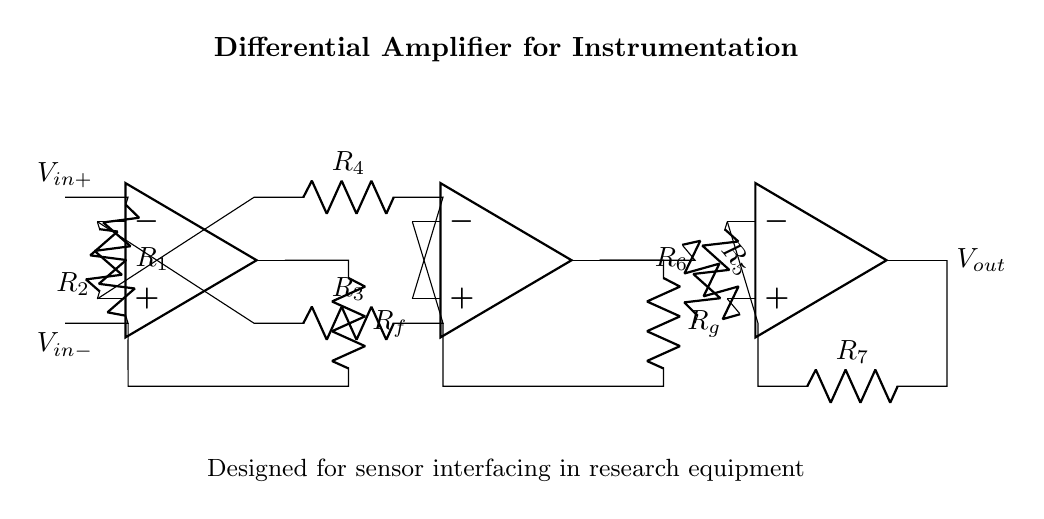What are the resistors labeled R1 and R2 used for? R1 and R2 are connected to the non-inverting and inverting inputs of the first operational amplifier, respectively, forming the input stage of the differential amplifier.
Answer: Input resistors What is the role of the operational amplifiers in this circuit? The operational amplifiers amplify the difference between the input voltages, V_in+ and V_in-, allowing the circuit to function as a differential amplifier for sensor signals.
Answer: Amplification How many operational amplifiers are present in the circuit? By counting the symbols for the operational amplifiers drawn in the circuit, we see there are three operational amplifiers present.
Answer: Three What is the purpose of the feedback resistors Rf and Rg? Rf and Rg provide negative feedback to the first and second operational amplifiers, which stabilizes the gain and helps control the overall response of the circuit.
Answer: Feedback control What is the output voltage represented by in the diagram? The output voltage, V_out, is displayed at the terminal connected to the last operational amplifier, indicating the amplified result of the input differential signal.
Answer: V_out How does this circuit improve measurement accuracy in instrumentation? The differential amplifier circuit rejects common-mode noise and amplifies only the difference between the input signals, enhancing measurement fidelity.
Answer: Improved accuracy What can be inferred about the relationship between V_in+ and V_in- in this circuit? A differential amplifier outputs a voltage proportional to the difference between V_in+ and V_in-, meaning that the circuit is designed to measure and amplify this voltage difference, regardless of their individual values.
Answer: Voltage difference 